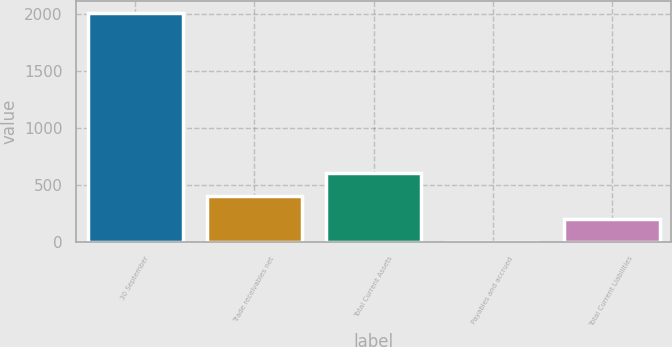<chart> <loc_0><loc_0><loc_500><loc_500><bar_chart><fcel>30 September<fcel>Trade receivables net<fcel>Total Current Assets<fcel>Payables and accrued<fcel>Total Current Liabilities<nl><fcel>2013<fcel>404.52<fcel>605.58<fcel>2.4<fcel>203.46<nl></chart> 